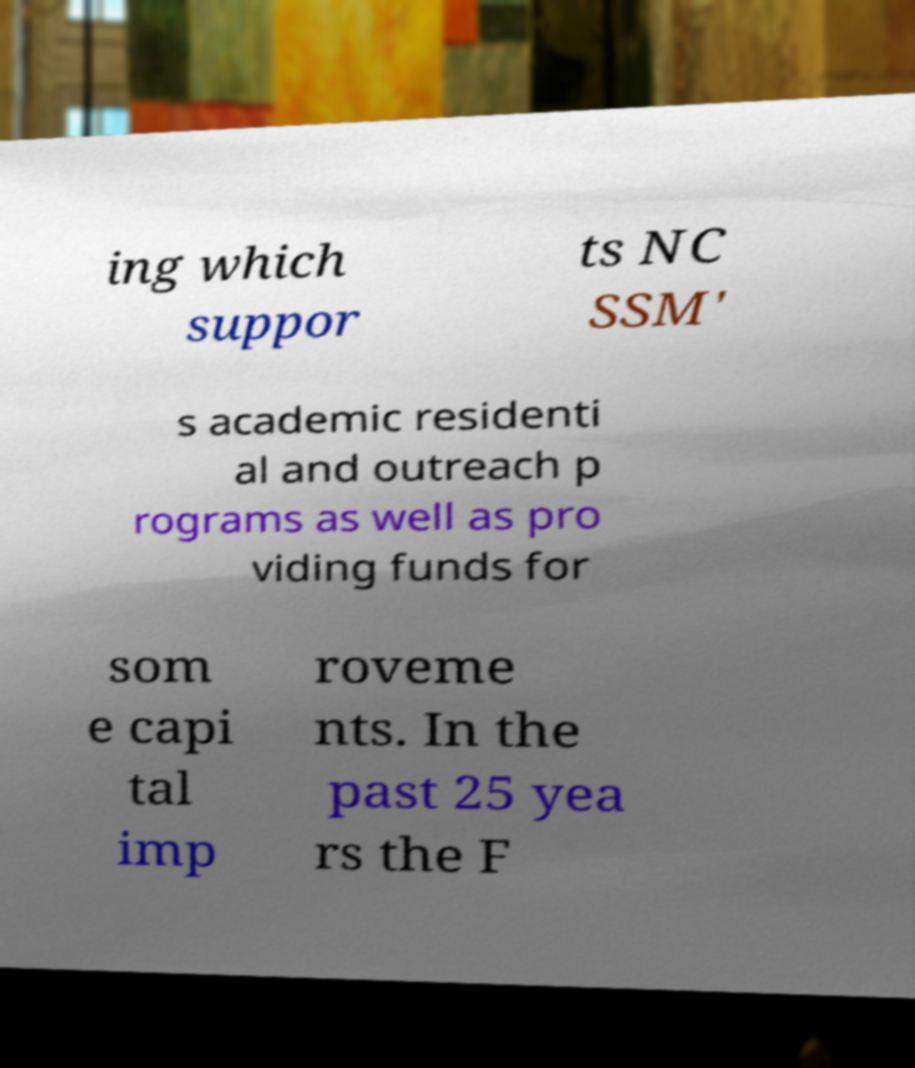Please read and relay the text visible in this image. What does it say? ing which suppor ts NC SSM' s academic residenti al and outreach p rograms as well as pro viding funds for som e capi tal imp roveme nts. In the past 25 yea rs the F 